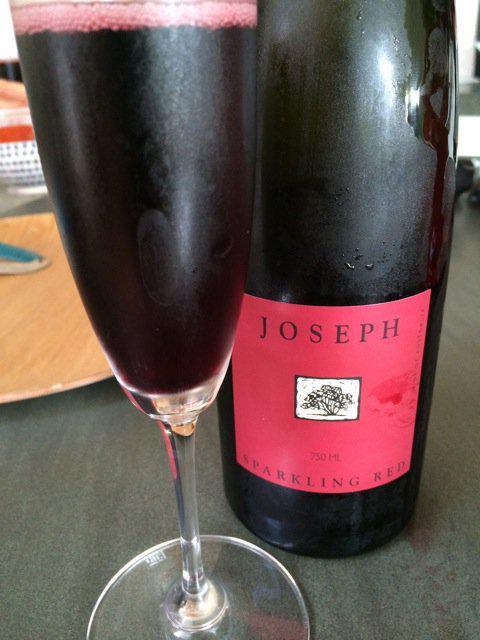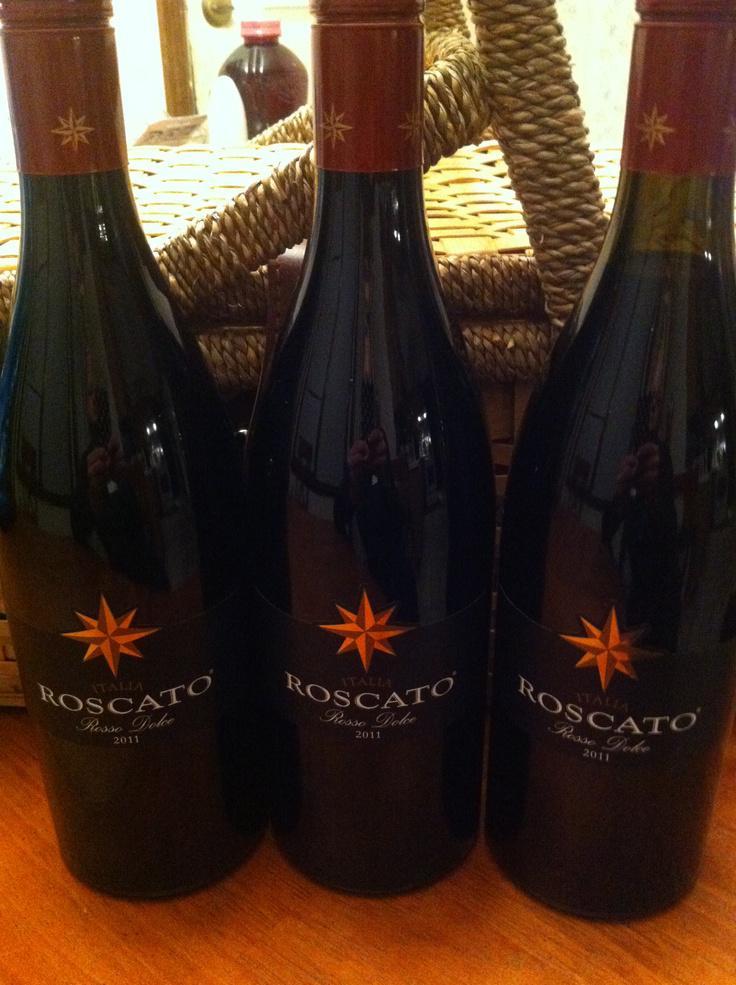The first image is the image on the left, the second image is the image on the right. Analyze the images presented: Is the assertion "One image shows only part of one wine glass and part of one bottle of wine." valid? Answer yes or no. Yes. The first image is the image on the left, the second image is the image on the right. Considering the images on both sides, is "There are 2 bottles of wine standing upright." valid? Answer yes or no. No. 